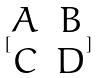<formula> <loc_0><loc_0><loc_500><loc_500>[ \begin{matrix} A & B \\ C & D \\ \end{matrix} ]</formula> 